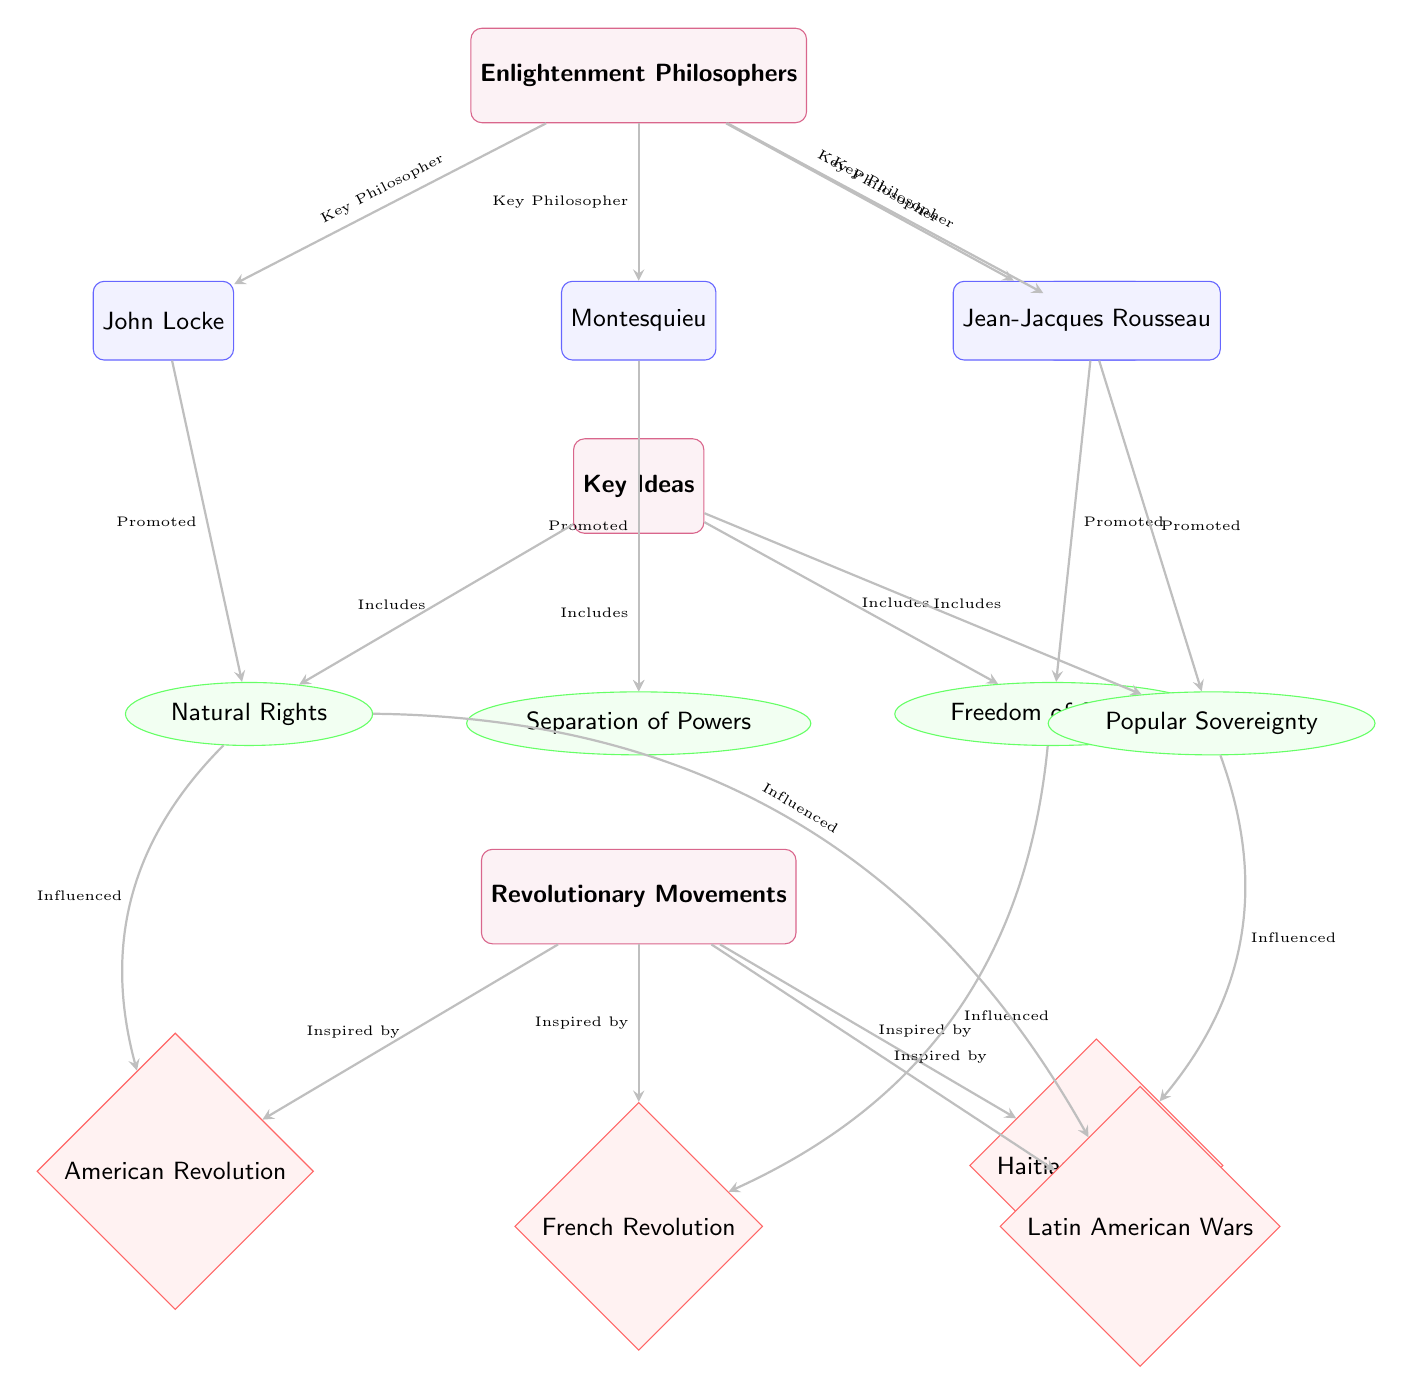What are the key figures of the Enlightenment philosophers? The diagram lists John Locke, Montesquieu, Voltaire, and Jean-Jacques Rousseau as key figures, indicated by the nodes branching from the "Enlightenment Philosophers" group node.
Answer: John Locke, Montesquieu, Voltaire, Jean-Jacques Rousseau Which key idea did Montesquieu promote? The diagram shows an arrow from Montesquieu to the "Separation of Powers," indicating that Montesquieu is associated with promoting this idea.
Answer: Separation of Powers How many revolutionary movements are represented in the diagram? The diagram shows four revolutionary movements: American Revolution, French Revolution, Haitian Revolution, and Latin American Wars, clearly displayed under the "Revolutionary Movements" group.
Answer: Four Which key idea influenced the French Revolution? The diagram illustrates a direct line from "Freedom of Speech" to the French Revolution, indicating that this key idea had an influence on the revolution.
Answer: Freedom of Speech What type of relationship exists between key ideas and revolutionary movements? The diagram specifies the relationship as "Inspired by," which connects the "Revolutionary Movements" node to individual movements, showing that they are inspired by the collective key ideas.
Answer: Inspired by How many key ideas are included in the diagram? There are four key ideas listed in the diagram: Natural Rights, Separation of Powers, Freedom of Speech, and Popular Sovereignty, all connected under the "Key Ideas" group node.
Answer: Four Which Enlightenment philosopher is connected to Natural Rights? Looking at the diagram, John Locke has a direct connection to the "Natural Rights" idea, which indicates his influence or promotion of this concept.
Answer: John Locke What influence did Popular Sovereignty have? From the diagram, the "Popular Sovereignty" idea influenced the Haitian Revolution, as indicated by the arrow showing this relationship.
Answer: Haitian Revolution Which Enlightenment philosopher is associated with Freedom of Speech? The diagram shows that Voltaire promotes the idea of "Freedom of Speech," linking him directly to this key concept.
Answer: Voltaire 